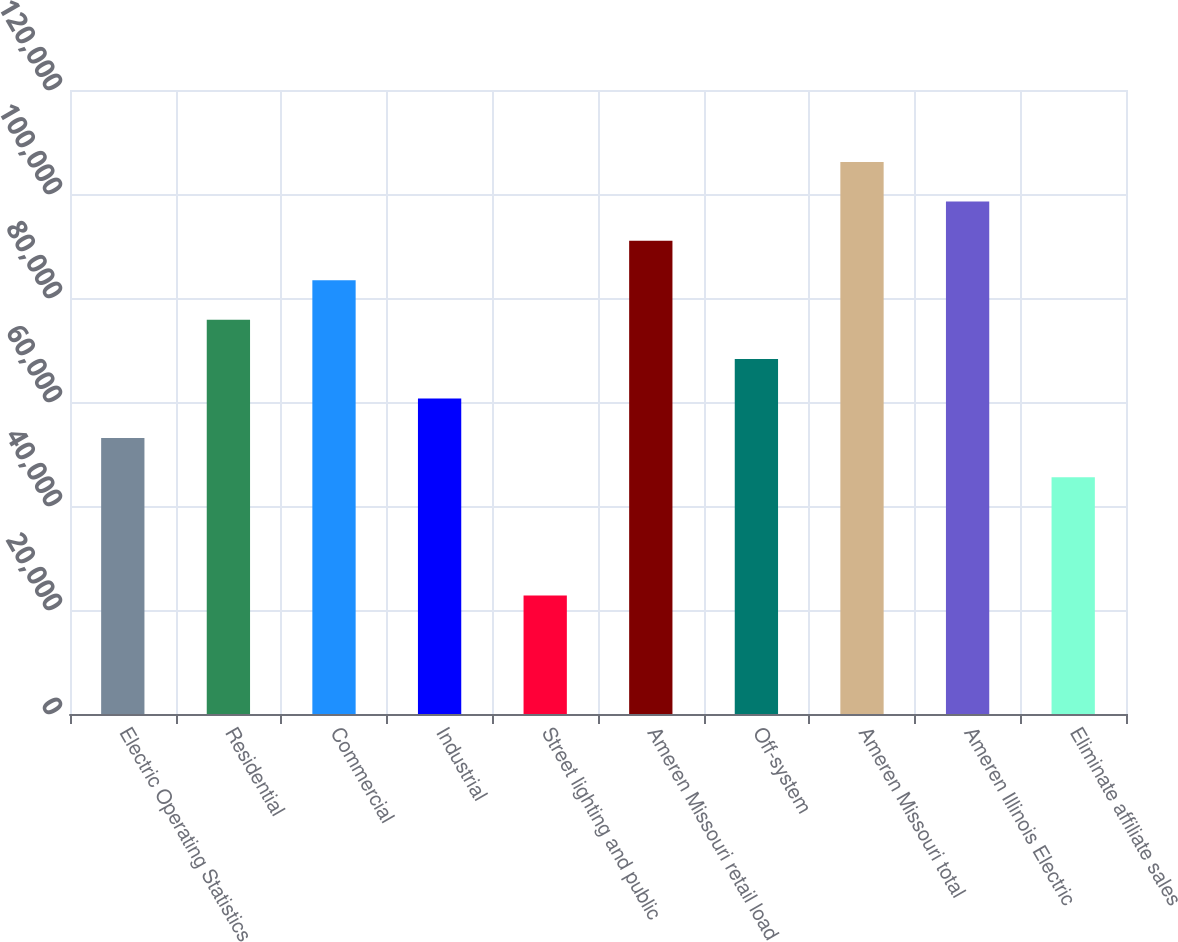Convert chart. <chart><loc_0><loc_0><loc_500><loc_500><bar_chart><fcel>Electric Operating Statistics<fcel>Residential<fcel>Commercial<fcel>Industrial<fcel>Street lighting and public<fcel>Ameren Missouri retail load<fcel>Off-system<fcel>Ameren Missouri total<fcel>Ameren Illinois Electric<fcel>Eliminate affiliate sales<nl><fcel>53093.7<fcel>75831<fcel>83410.1<fcel>60672.8<fcel>22777.3<fcel>90989.2<fcel>68251.9<fcel>106147<fcel>98568.3<fcel>45514.6<nl></chart> 